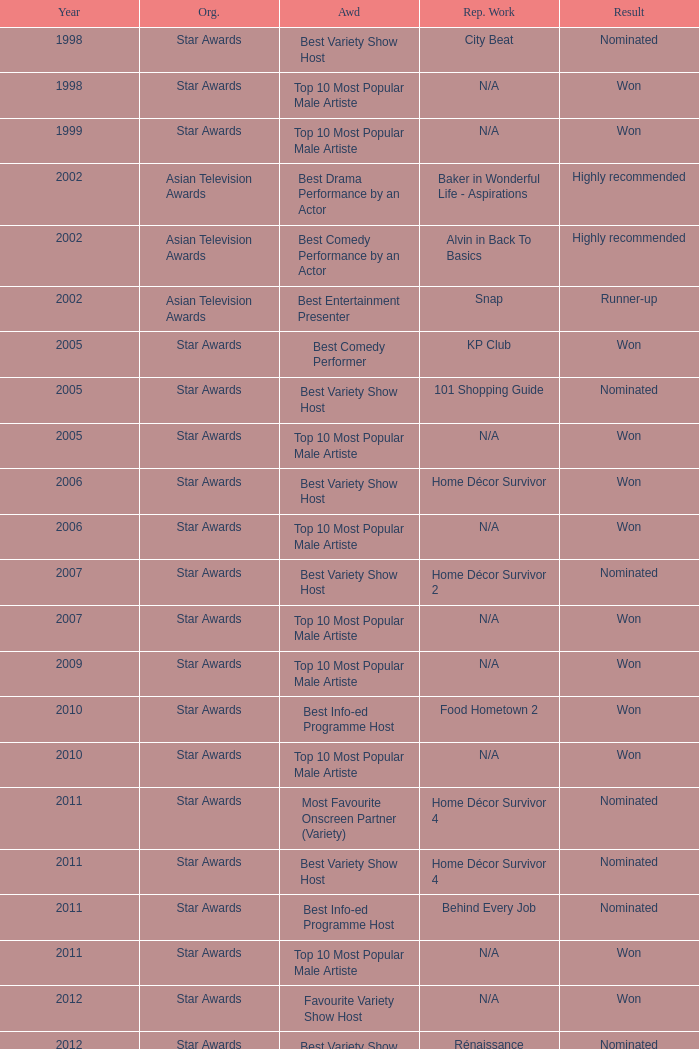What is the organisation in 2011 that was nominated and the award of best info-ed programme host? Star Awards. 